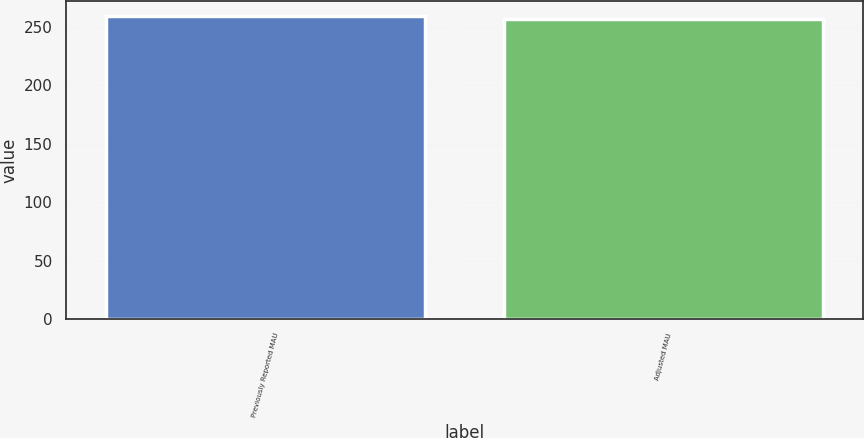<chart> <loc_0><loc_0><loc_500><loc_500><bar_chart><fcel>Previously Reported MAU<fcel>Adjusted MAU<nl><fcel>259<fcel>257<nl></chart> 